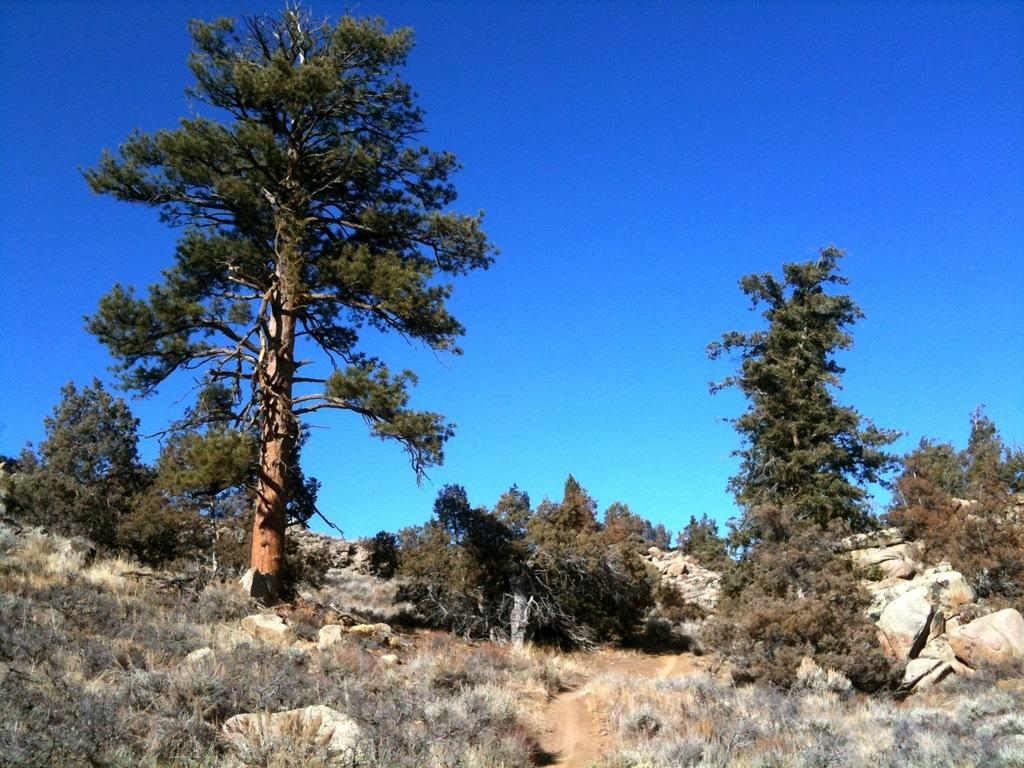What type of natural elements can be seen in the image? There are many trees and plants in the image. What other objects can be seen on the ground in the image? There are stones in the image. What part of the natural environment is visible in the image? The ground is visible in the image. What is the condition of the sky in the background of the image? The sky is clear in the background of the image. How many kittens are playing with the stones in the image? There are no kittens present in the image; it features trees, plants, and stones. How long does it take for the trees to grow in the image, measured in minutes? The growth rate of the trees cannot be determined from the image, and the concept of measuring time in minutes is not applicable to the growth of trees. 